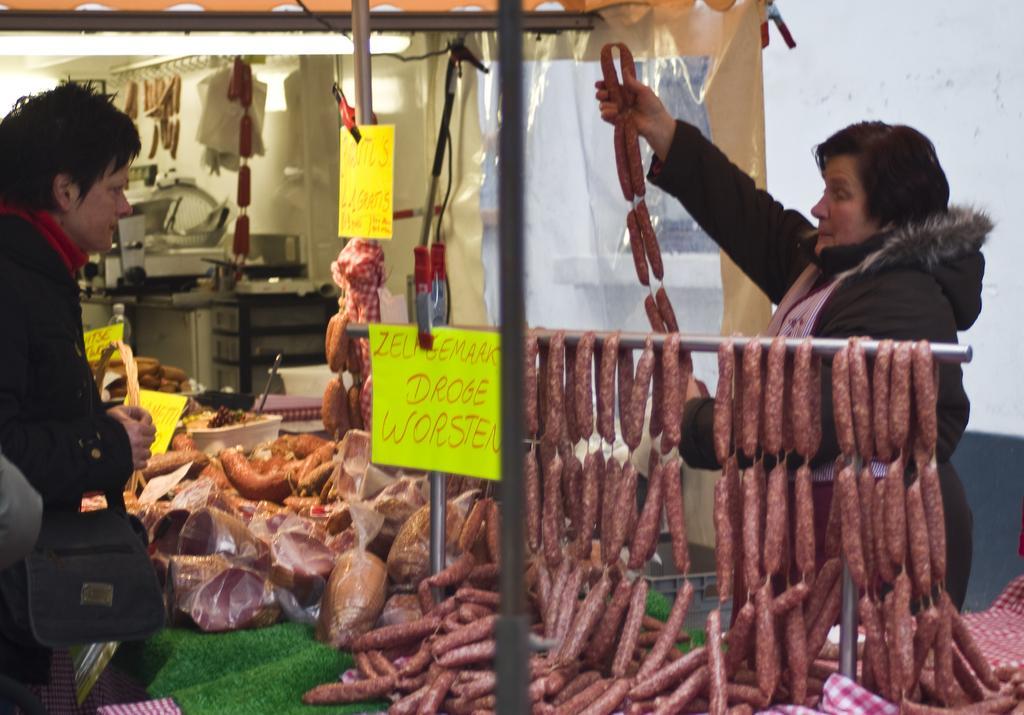In one or two sentences, can you explain what this image depicts? In this image there is a woman standing is holding salami in her hand, in front of the woman on the table and on the metal rod there is salami and some other meat items and there are display boards with some text on it. In front of the table there is another woman standing by holding some objects in her hand. In the background of the image there is salami and some other objects hanging and there are some other machines, behind the machines there is a wall, in front of the wall there is a cover. At the top of the image there are metal rods and cables. 